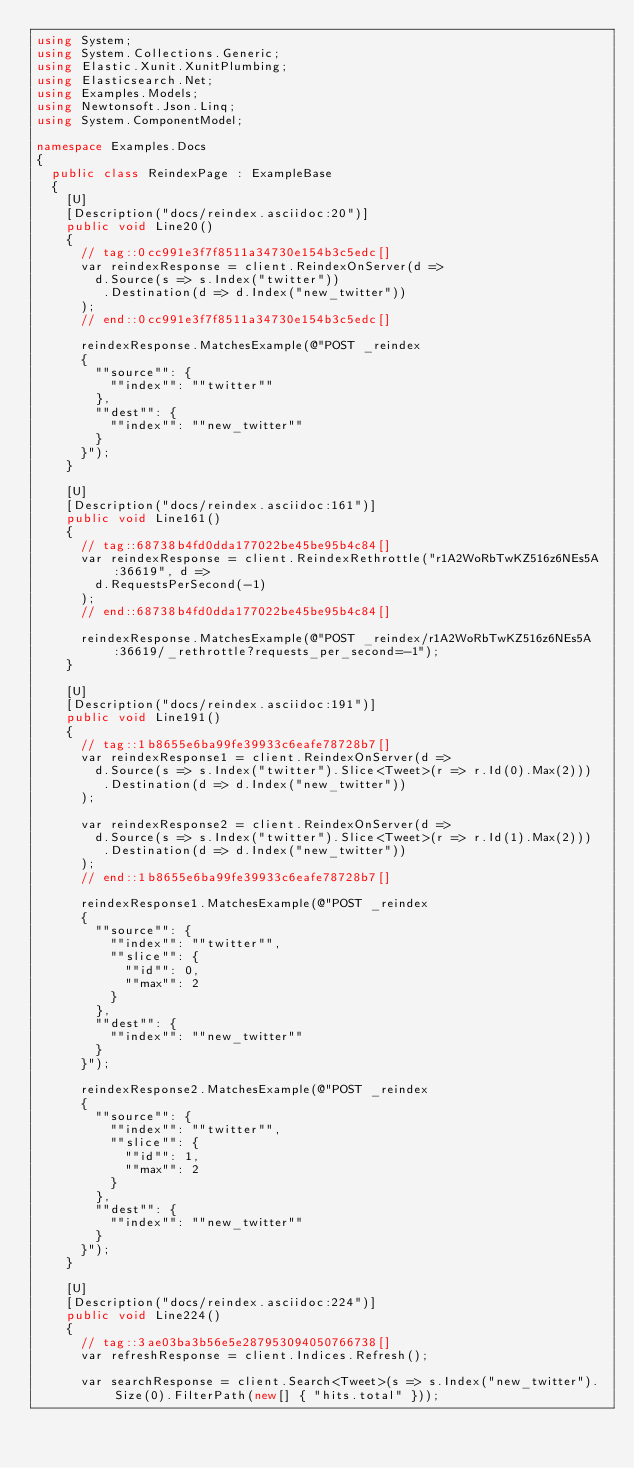<code> <loc_0><loc_0><loc_500><loc_500><_C#_>using System;
using System.Collections.Generic;
using Elastic.Xunit.XunitPlumbing;
using Elasticsearch.Net;
using Examples.Models;
using Newtonsoft.Json.Linq;
using System.ComponentModel;

namespace Examples.Docs
{
	public class ReindexPage : ExampleBase
	{
		[U]
		[Description("docs/reindex.asciidoc:20")]
		public void Line20()
		{
			// tag::0cc991e3f7f8511a34730e154b3c5edc[]
			var reindexResponse = client.ReindexOnServer(d =>
				d.Source(s => s.Index("twitter"))
				 .Destination(d => d.Index("new_twitter"))
			);
			// end::0cc991e3f7f8511a34730e154b3c5edc[]

			reindexResponse.MatchesExample(@"POST _reindex
			{
			  ""source"": {
			    ""index"": ""twitter""
			  },
			  ""dest"": {
			    ""index"": ""new_twitter""
			  }
			}");
		}

		[U]
		[Description("docs/reindex.asciidoc:161")]
		public void Line161()
		{
			// tag::68738b4fd0dda177022be45be95b4c84[]
			var reindexResponse = client.ReindexRethrottle("r1A2WoRbTwKZ516z6NEs5A:36619", d =>
				d.RequestsPerSecond(-1)
			);
			// end::68738b4fd0dda177022be45be95b4c84[]

			reindexResponse.MatchesExample(@"POST _reindex/r1A2WoRbTwKZ516z6NEs5A:36619/_rethrottle?requests_per_second=-1");
		}

		[U]
		[Description("docs/reindex.asciidoc:191")]
		public void Line191()
		{
			// tag::1b8655e6ba99fe39933c6eafe78728b7[]
			var reindexResponse1 = client.ReindexOnServer(d =>
				d.Source(s => s.Index("twitter").Slice<Tweet>(r => r.Id(0).Max(2)))
				 .Destination(d => d.Index("new_twitter"))
			);

			var reindexResponse2 = client.ReindexOnServer(d =>
				d.Source(s => s.Index("twitter").Slice<Tweet>(r => r.Id(1).Max(2)))
				 .Destination(d => d.Index("new_twitter"))
			);
			// end::1b8655e6ba99fe39933c6eafe78728b7[]

			reindexResponse1.MatchesExample(@"POST _reindex
			{
			  ""source"": {
			    ""index"": ""twitter"",
			    ""slice"": {
			      ""id"": 0,
			      ""max"": 2
			    }
			  },
			  ""dest"": {
			    ""index"": ""new_twitter""
			  }
			}");

			reindexResponse2.MatchesExample(@"POST _reindex
			{
			  ""source"": {
			    ""index"": ""twitter"",
			    ""slice"": {
			      ""id"": 1,
			      ""max"": 2
			    }
			  },
			  ""dest"": {
			    ""index"": ""new_twitter""
			  }
			}");
		}

		[U]
		[Description("docs/reindex.asciidoc:224")]
		public void Line224()
		{
			// tag::3ae03ba3b56e5e287953094050766738[]
			var refreshResponse = client.Indices.Refresh();

			var searchResponse = client.Search<Tweet>(s => s.Index("new_twitter").Size(0).FilterPath(new[] { "hits.total" }));</code> 